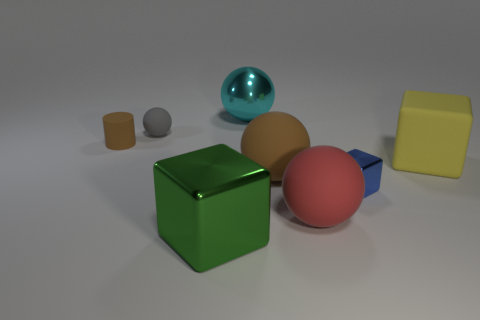Subtract 1 balls. How many balls are left? 3 Subtract all purple balls. Subtract all gray blocks. How many balls are left? 4 Add 1 yellow shiny objects. How many objects exist? 9 Subtract all cylinders. How many objects are left? 7 Subtract 1 cyan spheres. How many objects are left? 7 Subtract all big purple rubber cubes. Subtract all big green cubes. How many objects are left? 7 Add 7 cubes. How many cubes are left? 10 Add 6 brown matte objects. How many brown matte objects exist? 8 